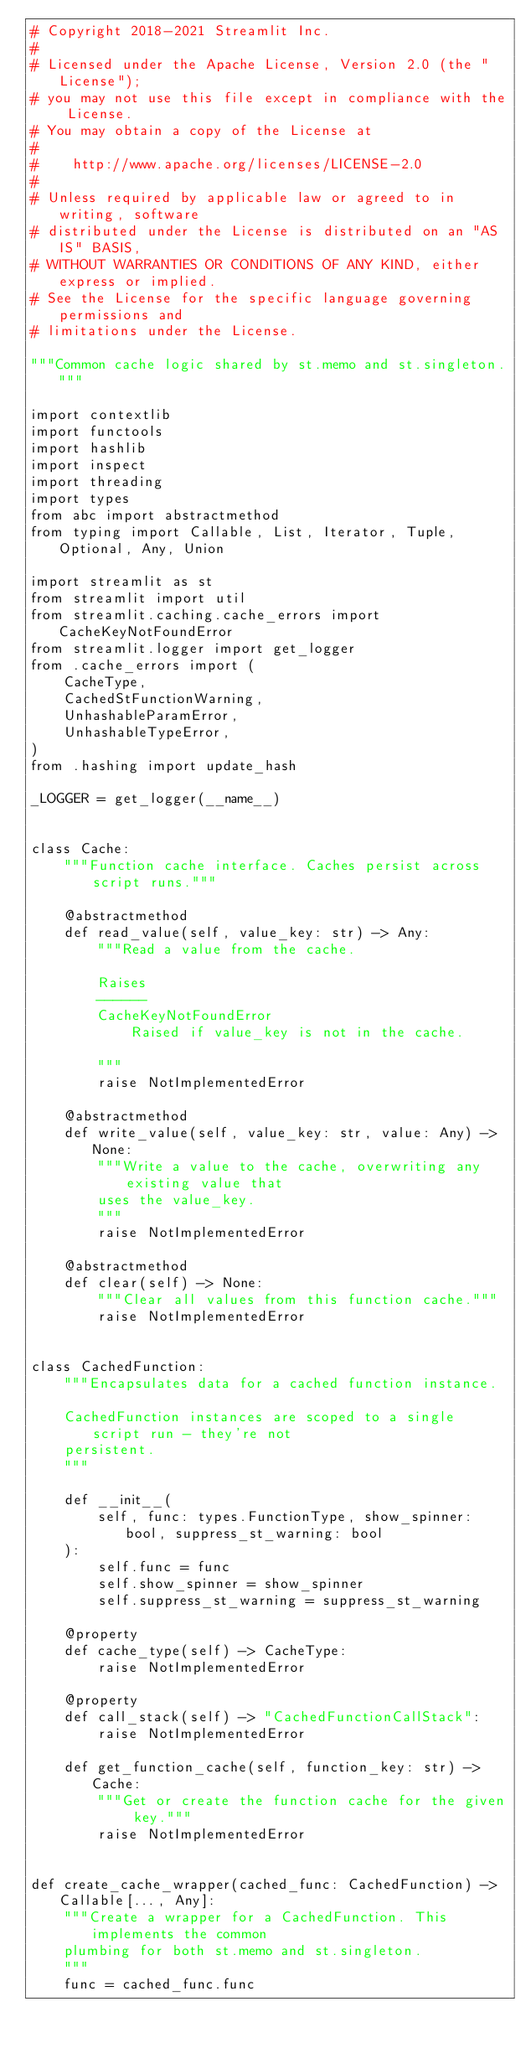<code> <loc_0><loc_0><loc_500><loc_500><_Python_># Copyright 2018-2021 Streamlit Inc.
#
# Licensed under the Apache License, Version 2.0 (the "License");
# you may not use this file except in compliance with the License.
# You may obtain a copy of the License at
#
#    http://www.apache.org/licenses/LICENSE-2.0
#
# Unless required by applicable law or agreed to in writing, software
# distributed under the License is distributed on an "AS IS" BASIS,
# WITHOUT WARRANTIES OR CONDITIONS OF ANY KIND, either express or implied.
# See the License for the specific language governing permissions and
# limitations under the License.

"""Common cache logic shared by st.memo and st.singleton."""

import contextlib
import functools
import hashlib
import inspect
import threading
import types
from abc import abstractmethod
from typing import Callable, List, Iterator, Tuple, Optional, Any, Union

import streamlit as st
from streamlit import util
from streamlit.caching.cache_errors import CacheKeyNotFoundError
from streamlit.logger import get_logger
from .cache_errors import (
    CacheType,
    CachedStFunctionWarning,
    UnhashableParamError,
    UnhashableTypeError,
)
from .hashing import update_hash

_LOGGER = get_logger(__name__)


class Cache:
    """Function cache interface. Caches persist across script runs."""

    @abstractmethod
    def read_value(self, value_key: str) -> Any:
        """Read a value from the cache.

        Raises
        ------
        CacheKeyNotFoundError
            Raised if value_key is not in the cache.

        """
        raise NotImplementedError

    @abstractmethod
    def write_value(self, value_key: str, value: Any) -> None:
        """Write a value to the cache, overwriting any existing value that
        uses the value_key.
        """
        raise NotImplementedError

    @abstractmethod
    def clear(self) -> None:
        """Clear all values from this function cache."""
        raise NotImplementedError


class CachedFunction:
    """Encapsulates data for a cached function instance.

    CachedFunction instances are scoped to a single script run - they're not
    persistent.
    """

    def __init__(
        self, func: types.FunctionType, show_spinner: bool, suppress_st_warning: bool
    ):
        self.func = func
        self.show_spinner = show_spinner
        self.suppress_st_warning = suppress_st_warning

    @property
    def cache_type(self) -> CacheType:
        raise NotImplementedError

    @property
    def call_stack(self) -> "CachedFunctionCallStack":
        raise NotImplementedError

    def get_function_cache(self, function_key: str) -> Cache:
        """Get or create the function cache for the given key."""
        raise NotImplementedError


def create_cache_wrapper(cached_func: CachedFunction) -> Callable[..., Any]:
    """Create a wrapper for a CachedFunction. This implements the common
    plumbing for both st.memo and st.singleton.
    """
    func = cached_func.func</code> 